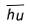<formula> <loc_0><loc_0><loc_500><loc_500>\overline { h u }</formula> 